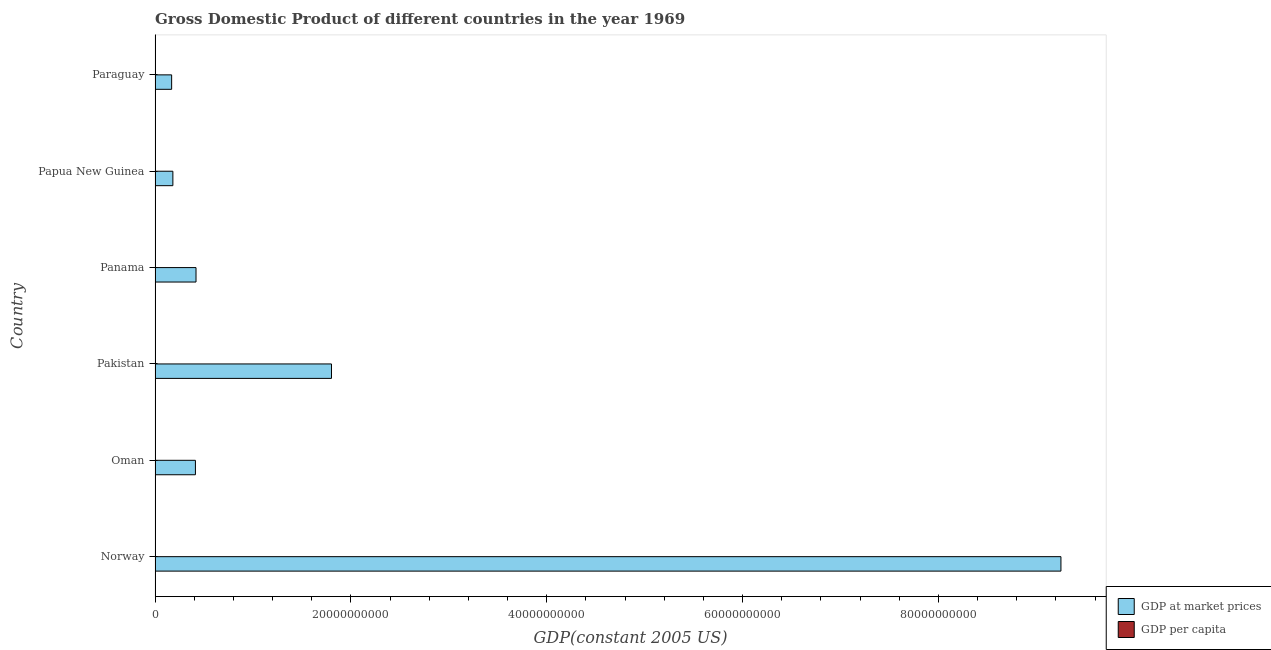How many different coloured bars are there?
Keep it short and to the point. 2. Are the number of bars per tick equal to the number of legend labels?
Offer a very short reply. Yes. How many bars are there on the 6th tick from the bottom?
Your response must be concise. 2. What is the label of the 1st group of bars from the top?
Provide a succinct answer. Paraguay. What is the gdp per capita in Oman?
Provide a succinct answer. 5882.22. Across all countries, what is the maximum gdp at market prices?
Provide a short and direct response. 9.25e+1. Across all countries, what is the minimum gdp at market prices?
Make the answer very short. 1.69e+09. In which country was the gdp at market prices maximum?
Ensure brevity in your answer.  Norway. In which country was the gdp per capita minimum?
Your response must be concise. Pakistan. What is the total gdp per capita in the graph?
Make the answer very short. 3.45e+04. What is the difference between the gdp per capita in Papua New Guinea and that in Paraguay?
Your response must be concise. 65.75. What is the difference between the gdp at market prices in Paraguay and the gdp per capita in Oman?
Make the answer very short. 1.69e+09. What is the average gdp at market prices per country?
Your response must be concise. 2.04e+1. What is the difference between the gdp at market prices and gdp per capita in Norway?
Make the answer very short. 9.25e+1. In how many countries, is the gdp per capita greater than 88000000000 US$?
Provide a succinct answer. 0. What is the ratio of the gdp at market prices in Norway to that in Paraguay?
Keep it short and to the point. 54.65. Is the difference between the gdp at market prices in Oman and Pakistan greater than the difference between the gdp per capita in Oman and Pakistan?
Offer a very short reply. No. What is the difference between the highest and the second highest gdp at market prices?
Give a very brief answer. 7.45e+1. What is the difference between the highest and the lowest gdp per capita?
Your answer should be very brief. 2.37e+04. Is the sum of the gdp per capita in Norway and Panama greater than the maximum gdp at market prices across all countries?
Keep it short and to the point. No. What does the 2nd bar from the top in Oman represents?
Provide a short and direct response. GDP at market prices. What does the 1st bar from the bottom in Paraguay represents?
Your response must be concise. GDP at market prices. How many bars are there?
Your answer should be very brief. 12. Are all the bars in the graph horizontal?
Your response must be concise. Yes. How many countries are there in the graph?
Provide a succinct answer. 6. Are the values on the major ticks of X-axis written in scientific E-notation?
Your answer should be very brief. No. Does the graph contain grids?
Your response must be concise. No. How are the legend labels stacked?
Your response must be concise. Vertical. What is the title of the graph?
Your answer should be very brief. Gross Domestic Product of different countries in the year 1969. Does "Gasoline" appear as one of the legend labels in the graph?
Offer a terse response. No. What is the label or title of the X-axis?
Your answer should be compact. GDP(constant 2005 US). What is the GDP(constant 2005 US) in GDP at market prices in Norway?
Your answer should be compact. 9.25e+1. What is the GDP(constant 2005 US) in GDP per capita in Norway?
Provide a short and direct response. 2.40e+04. What is the GDP(constant 2005 US) of GDP at market prices in Oman?
Keep it short and to the point. 4.12e+09. What is the GDP(constant 2005 US) in GDP per capita in Oman?
Your answer should be very brief. 5882.22. What is the GDP(constant 2005 US) in GDP at market prices in Pakistan?
Ensure brevity in your answer.  1.80e+1. What is the GDP(constant 2005 US) of GDP per capita in Pakistan?
Offer a terse response. 318.63. What is the GDP(constant 2005 US) in GDP at market prices in Panama?
Ensure brevity in your answer.  4.18e+09. What is the GDP(constant 2005 US) in GDP per capita in Panama?
Keep it short and to the point. 2832.95. What is the GDP(constant 2005 US) in GDP at market prices in Papua New Guinea?
Offer a very short reply. 1.82e+09. What is the GDP(constant 2005 US) of GDP per capita in Papua New Guinea?
Make the answer very short. 767.43. What is the GDP(constant 2005 US) in GDP at market prices in Paraguay?
Provide a short and direct response. 1.69e+09. What is the GDP(constant 2005 US) of GDP per capita in Paraguay?
Your answer should be very brief. 701.68. Across all countries, what is the maximum GDP(constant 2005 US) in GDP at market prices?
Your answer should be compact. 9.25e+1. Across all countries, what is the maximum GDP(constant 2005 US) of GDP per capita?
Your answer should be very brief. 2.40e+04. Across all countries, what is the minimum GDP(constant 2005 US) in GDP at market prices?
Ensure brevity in your answer.  1.69e+09. Across all countries, what is the minimum GDP(constant 2005 US) of GDP per capita?
Give a very brief answer. 318.63. What is the total GDP(constant 2005 US) of GDP at market prices in the graph?
Ensure brevity in your answer.  1.22e+11. What is the total GDP(constant 2005 US) of GDP per capita in the graph?
Your response must be concise. 3.45e+04. What is the difference between the GDP(constant 2005 US) in GDP at market prices in Norway and that in Oman?
Keep it short and to the point. 8.84e+1. What is the difference between the GDP(constant 2005 US) in GDP per capita in Norway and that in Oman?
Your response must be concise. 1.82e+04. What is the difference between the GDP(constant 2005 US) in GDP at market prices in Norway and that in Pakistan?
Provide a short and direct response. 7.45e+1. What is the difference between the GDP(constant 2005 US) of GDP per capita in Norway and that in Pakistan?
Offer a terse response. 2.37e+04. What is the difference between the GDP(constant 2005 US) of GDP at market prices in Norway and that in Panama?
Provide a succinct answer. 8.83e+1. What is the difference between the GDP(constant 2005 US) in GDP per capita in Norway and that in Panama?
Ensure brevity in your answer.  2.12e+04. What is the difference between the GDP(constant 2005 US) of GDP at market prices in Norway and that in Papua New Guinea?
Your answer should be compact. 9.07e+1. What is the difference between the GDP(constant 2005 US) in GDP per capita in Norway and that in Papua New Guinea?
Your response must be concise. 2.33e+04. What is the difference between the GDP(constant 2005 US) of GDP at market prices in Norway and that in Paraguay?
Your answer should be compact. 9.08e+1. What is the difference between the GDP(constant 2005 US) of GDP per capita in Norway and that in Paraguay?
Your answer should be compact. 2.33e+04. What is the difference between the GDP(constant 2005 US) of GDP at market prices in Oman and that in Pakistan?
Make the answer very short. -1.39e+1. What is the difference between the GDP(constant 2005 US) in GDP per capita in Oman and that in Pakistan?
Give a very brief answer. 5563.58. What is the difference between the GDP(constant 2005 US) in GDP at market prices in Oman and that in Panama?
Your answer should be compact. -6.10e+07. What is the difference between the GDP(constant 2005 US) of GDP per capita in Oman and that in Panama?
Provide a short and direct response. 3049.26. What is the difference between the GDP(constant 2005 US) in GDP at market prices in Oman and that in Papua New Guinea?
Provide a short and direct response. 2.30e+09. What is the difference between the GDP(constant 2005 US) in GDP per capita in Oman and that in Papua New Guinea?
Your answer should be compact. 5114.79. What is the difference between the GDP(constant 2005 US) in GDP at market prices in Oman and that in Paraguay?
Give a very brief answer. 2.43e+09. What is the difference between the GDP(constant 2005 US) in GDP per capita in Oman and that in Paraguay?
Your answer should be compact. 5180.54. What is the difference between the GDP(constant 2005 US) in GDP at market prices in Pakistan and that in Panama?
Ensure brevity in your answer.  1.38e+1. What is the difference between the GDP(constant 2005 US) of GDP per capita in Pakistan and that in Panama?
Ensure brevity in your answer.  -2514.32. What is the difference between the GDP(constant 2005 US) in GDP at market prices in Pakistan and that in Papua New Guinea?
Provide a short and direct response. 1.62e+1. What is the difference between the GDP(constant 2005 US) of GDP per capita in Pakistan and that in Papua New Guinea?
Ensure brevity in your answer.  -448.79. What is the difference between the GDP(constant 2005 US) in GDP at market prices in Pakistan and that in Paraguay?
Your answer should be compact. 1.63e+1. What is the difference between the GDP(constant 2005 US) of GDP per capita in Pakistan and that in Paraguay?
Make the answer very short. -383.04. What is the difference between the GDP(constant 2005 US) of GDP at market prices in Panama and that in Papua New Guinea?
Provide a short and direct response. 2.36e+09. What is the difference between the GDP(constant 2005 US) of GDP per capita in Panama and that in Papua New Guinea?
Your response must be concise. 2065.52. What is the difference between the GDP(constant 2005 US) in GDP at market prices in Panama and that in Paraguay?
Give a very brief answer. 2.49e+09. What is the difference between the GDP(constant 2005 US) of GDP per capita in Panama and that in Paraguay?
Offer a very short reply. 2131.28. What is the difference between the GDP(constant 2005 US) of GDP at market prices in Papua New Guinea and that in Paraguay?
Ensure brevity in your answer.  1.27e+08. What is the difference between the GDP(constant 2005 US) of GDP per capita in Papua New Guinea and that in Paraguay?
Give a very brief answer. 65.75. What is the difference between the GDP(constant 2005 US) of GDP at market prices in Norway and the GDP(constant 2005 US) of GDP per capita in Oman?
Provide a succinct answer. 9.25e+1. What is the difference between the GDP(constant 2005 US) in GDP at market prices in Norway and the GDP(constant 2005 US) in GDP per capita in Pakistan?
Keep it short and to the point. 9.25e+1. What is the difference between the GDP(constant 2005 US) of GDP at market prices in Norway and the GDP(constant 2005 US) of GDP per capita in Panama?
Ensure brevity in your answer.  9.25e+1. What is the difference between the GDP(constant 2005 US) in GDP at market prices in Norway and the GDP(constant 2005 US) in GDP per capita in Papua New Guinea?
Offer a very short reply. 9.25e+1. What is the difference between the GDP(constant 2005 US) of GDP at market prices in Norway and the GDP(constant 2005 US) of GDP per capita in Paraguay?
Ensure brevity in your answer.  9.25e+1. What is the difference between the GDP(constant 2005 US) of GDP at market prices in Oman and the GDP(constant 2005 US) of GDP per capita in Pakistan?
Make the answer very short. 4.12e+09. What is the difference between the GDP(constant 2005 US) in GDP at market prices in Oman and the GDP(constant 2005 US) in GDP per capita in Panama?
Ensure brevity in your answer.  4.12e+09. What is the difference between the GDP(constant 2005 US) of GDP at market prices in Oman and the GDP(constant 2005 US) of GDP per capita in Papua New Guinea?
Offer a very short reply. 4.12e+09. What is the difference between the GDP(constant 2005 US) in GDP at market prices in Oman and the GDP(constant 2005 US) in GDP per capita in Paraguay?
Your answer should be compact. 4.12e+09. What is the difference between the GDP(constant 2005 US) of GDP at market prices in Pakistan and the GDP(constant 2005 US) of GDP per capita in Panama?
Keep it short and to the point. 1.80e+1. What is the difference between the GDP(constant 2005 US) of GDP at market prices in Pakistan and the GDP(constant 2005 US) of GDP per capita in Papua New Guinea?
Provide a succinct answer. 1.80e+1. What is the difference between the GDP(constant 2005 US) of GDP at market prices in Pakistan and the GDP(constant 2005 US) of GDP per capita in Paraguay?
Make the answer very short. 1.80e+1. What is the difference between the GDP(constant 2005 US) in GDP at market prices in Panama and the GDP(constant 2005 US) in GDP per capita in Papua New Guinea?
Your answer should be very brief. 4.18e+09. What is the difference between the GDP(constant 2005 US) of GDP at market prices in Panama and the GDP(constant 2005 US) of GDP per capita in Paraguay?
Keep it short and to the point. 4.18e+09. What is the difference between the GDP(constant 2005 US) in GDP at market prices in Papua New Guinea and the GDP(constant 2005 US) in GDP per capita in Paraguay?
Give a very brief answer. 1.82e+09. What is the average GDP(constant 2005 US) in GDP at market prices per country?
Keep it short and to the point. 2.04e+1. What is the average GDP(constant 2005 US) of GDP per capita per country?
Make the answer very short. 5757.85. What is the difference between the GDP(constant 2005 US) in GDP at market prices and GDP(constant 2005 US) in GDP per capita in Norway?
Your answer should be compact. 9.25e+1. What is the difference between the GDP(constant 2005 US) in GDP at market prices and GDP(constant 2005 US) in GDP per capita in Oman?
Your response must be concise. 4.12e+09. What is the difference between the GDP(constant 2005 US) in GDP at market prices and GDP(constant 2005 US) in GDP per capita in Pakistan?
Provide a short and direct response. 1.80e+1. What is the difference between the GDP(constant 2005 US) in GDP at market prices and GDP(constant 2005 US) in GDP per capita in Panama?
Ensure brevity in your answer.  4.18e+09. What is the difference between the GDP(constant 2005 US) in GDP at market prices and GDP(constant 2005 US) in GDP per capita in Papua New Guinea?
Your response must be concise. 1.82e+09. What is the difference between the GDP(constant 2005 US) in GDP at market prices and GDP(constant 2005 US) in GDP per capita in Paraguay?
Offer a very short reply. 1.69e+09. What is the ratio of the GDP(constant 2005 US) of GDP at market prices in Norway to that in Oman?
Offer a terse response. 22.45. What is the ratio of the GDP(constant 2005 US) of GDP per capita in Norway to that in Oman?
Offer a terse response. 4.09. What is the ratio of the GDP(constant 2005 US) in GDP at market prices in Norway to that in Pakistan?
Provide a short and direct response. 5.13. What is the ratio of the GDP(constant 2005 US) of GDP per capita in Norway to that in Pakistan?
Offer a terse response. 75.46. What is the ratio of the GDP(constant 2005 US) of GDP at market prices in Norway to that in Panama?
Provide a short and direct response. 22.12. What is the ratio of the GDP(constant 2005 US) of GDP per capita in Norway to that in Panama?
Make the answer very short. 8.49. What is the ratio of the GDP(constant 2005 US) of GDP at market prices in Norway to that in Papua New Guinea?
Your answer should be compact. 50.83. What is the ratio of the GDP(constant 2005 US) of GDP per capita in Norway to that in Papua New Guinea?
Provide a short and direct response. 31.33. What is the ratio of the GDP(constant 2005 US) of GDP at market prices in Norway to that in Paraguay?
Offer a terse response. 54.65. What is the ratio of the GDP(constant 2005 US) of GDP per capita in Norway to that in Paraguay?
Your response must be concise. 34.27. What is the ratio of the GDP(constant 2005 US) of GDP at market prices in Oman to that in Pakistan?
Give a very brief answer. 0.23. What is the ratio of the GDP(constant 2005 US) of GDP per capita in Oman to that in Pakistan?
Your answer should be very brief. 18.46. What is the ratio of the GDP(constant 2005 US) in GDP at market prices in Oman to that in Panama?
Ensure brevity in your answer.  0.99. What is the ratio of the GDP(constant 2005 US) of GDP per capita in Oman to that in Panama?
Make the answer very short. 2.08. What is the ratio of the GDP(constant 2005 US) of GDP at market prices in Oman to that in Papua New Guinea?
Provide a short and direct response. 2.26. What is the ratio of the GDP(constant 2005 US) in GDP per capita in Oman to that in Papua New Guinea?
Offer a terse response. 7.66. What is the ratio of the GDP(constant 2005 US) of GDP at market prices in Oman to that in Paraguay?
Make the answer very short. 2.43. What is the ratio of the GDP(constant 2005 US) of GDP per capita in Oman to that in Paraguay?
Provide a succinct answer. 8.38. What is the ratio of the GDP(constant 2005 US) of GDP at market prices in Pakistan to that in Panama?
Offer a terse response. 4.31. What is the ratio of the GDP(constant 2005 US) of GDP per capita in Pakistan to that in Panama?
Make the answer very short. 0.11. What is the ratio of the GDP(constant 2005 US) of GDP at market prices in Pakistan to that in Papua New Guinea?
Your answer should be compact. 9.9. What is the ratio of the GDP(constant 2005 US) of GDP per capita in Pakistan to that in Papua New Guinea?
Make the answer very short. 0.42. What is the ratio of the GDP(constant 2005 US) in GDP at market prices in Pakistan to that in Paraguay?
Provide a short and direct response. 10.64. What is the ratio of the GDP(constant 2005 US) in GDP per capita in Pakistan to that in Paraguay?
Give a very brief answer. 0.45. What is the ratio of the GDP(constant 2005 US) of GDP at market prices in Panama to that in Papua New Guinea?
Your response must be concise. 2.3. What is the ratio of the GDP(constant 2005 US) in GDP per capita in Panama to that in Papua New Guinea?
Give a very brief answer. 3.69. What is the ratio of the GDP(constant 2005 US) of GDP at market prices in Panama to that in Paraguay?
Provide a short and direct response. 2.47. What is the ratio of the GDP(constant 2005 US) in GDP per capita in Panama to that in Paraguay?
Your answer should be very brief. 4.04. What is the ratio of the GDP(constant 2005 US) in GDP at market prices in Papua New Guinea to that in Paraguay?
Provide a short and direct response. 1.08. What is the ratio of the GDP(constant 2005 US) of GDP per capita in Papua New Guinea to that in Paraguay?
Your answer should be very brief. 1.09. What is the difference between the highest and the second highest GDP(constant 2005 US) in GDP at market prices?
Provide a short and direct response. 7.45e+1. What is the difference between the highest and the second highest GDP(constant 2005 US) of GDP per capita?
Your answer should be very brief. 1.82e+04. What is the difference between the highest and the lowest GDP(constant 2005 US) of GDP at market prices?
Give a very brief answer. 9.08e+1. What is the difference between the highest and the lowest GDP(constant 2005 US) of GDP per capita?
Give a very brief answer. 2.37e+04. 